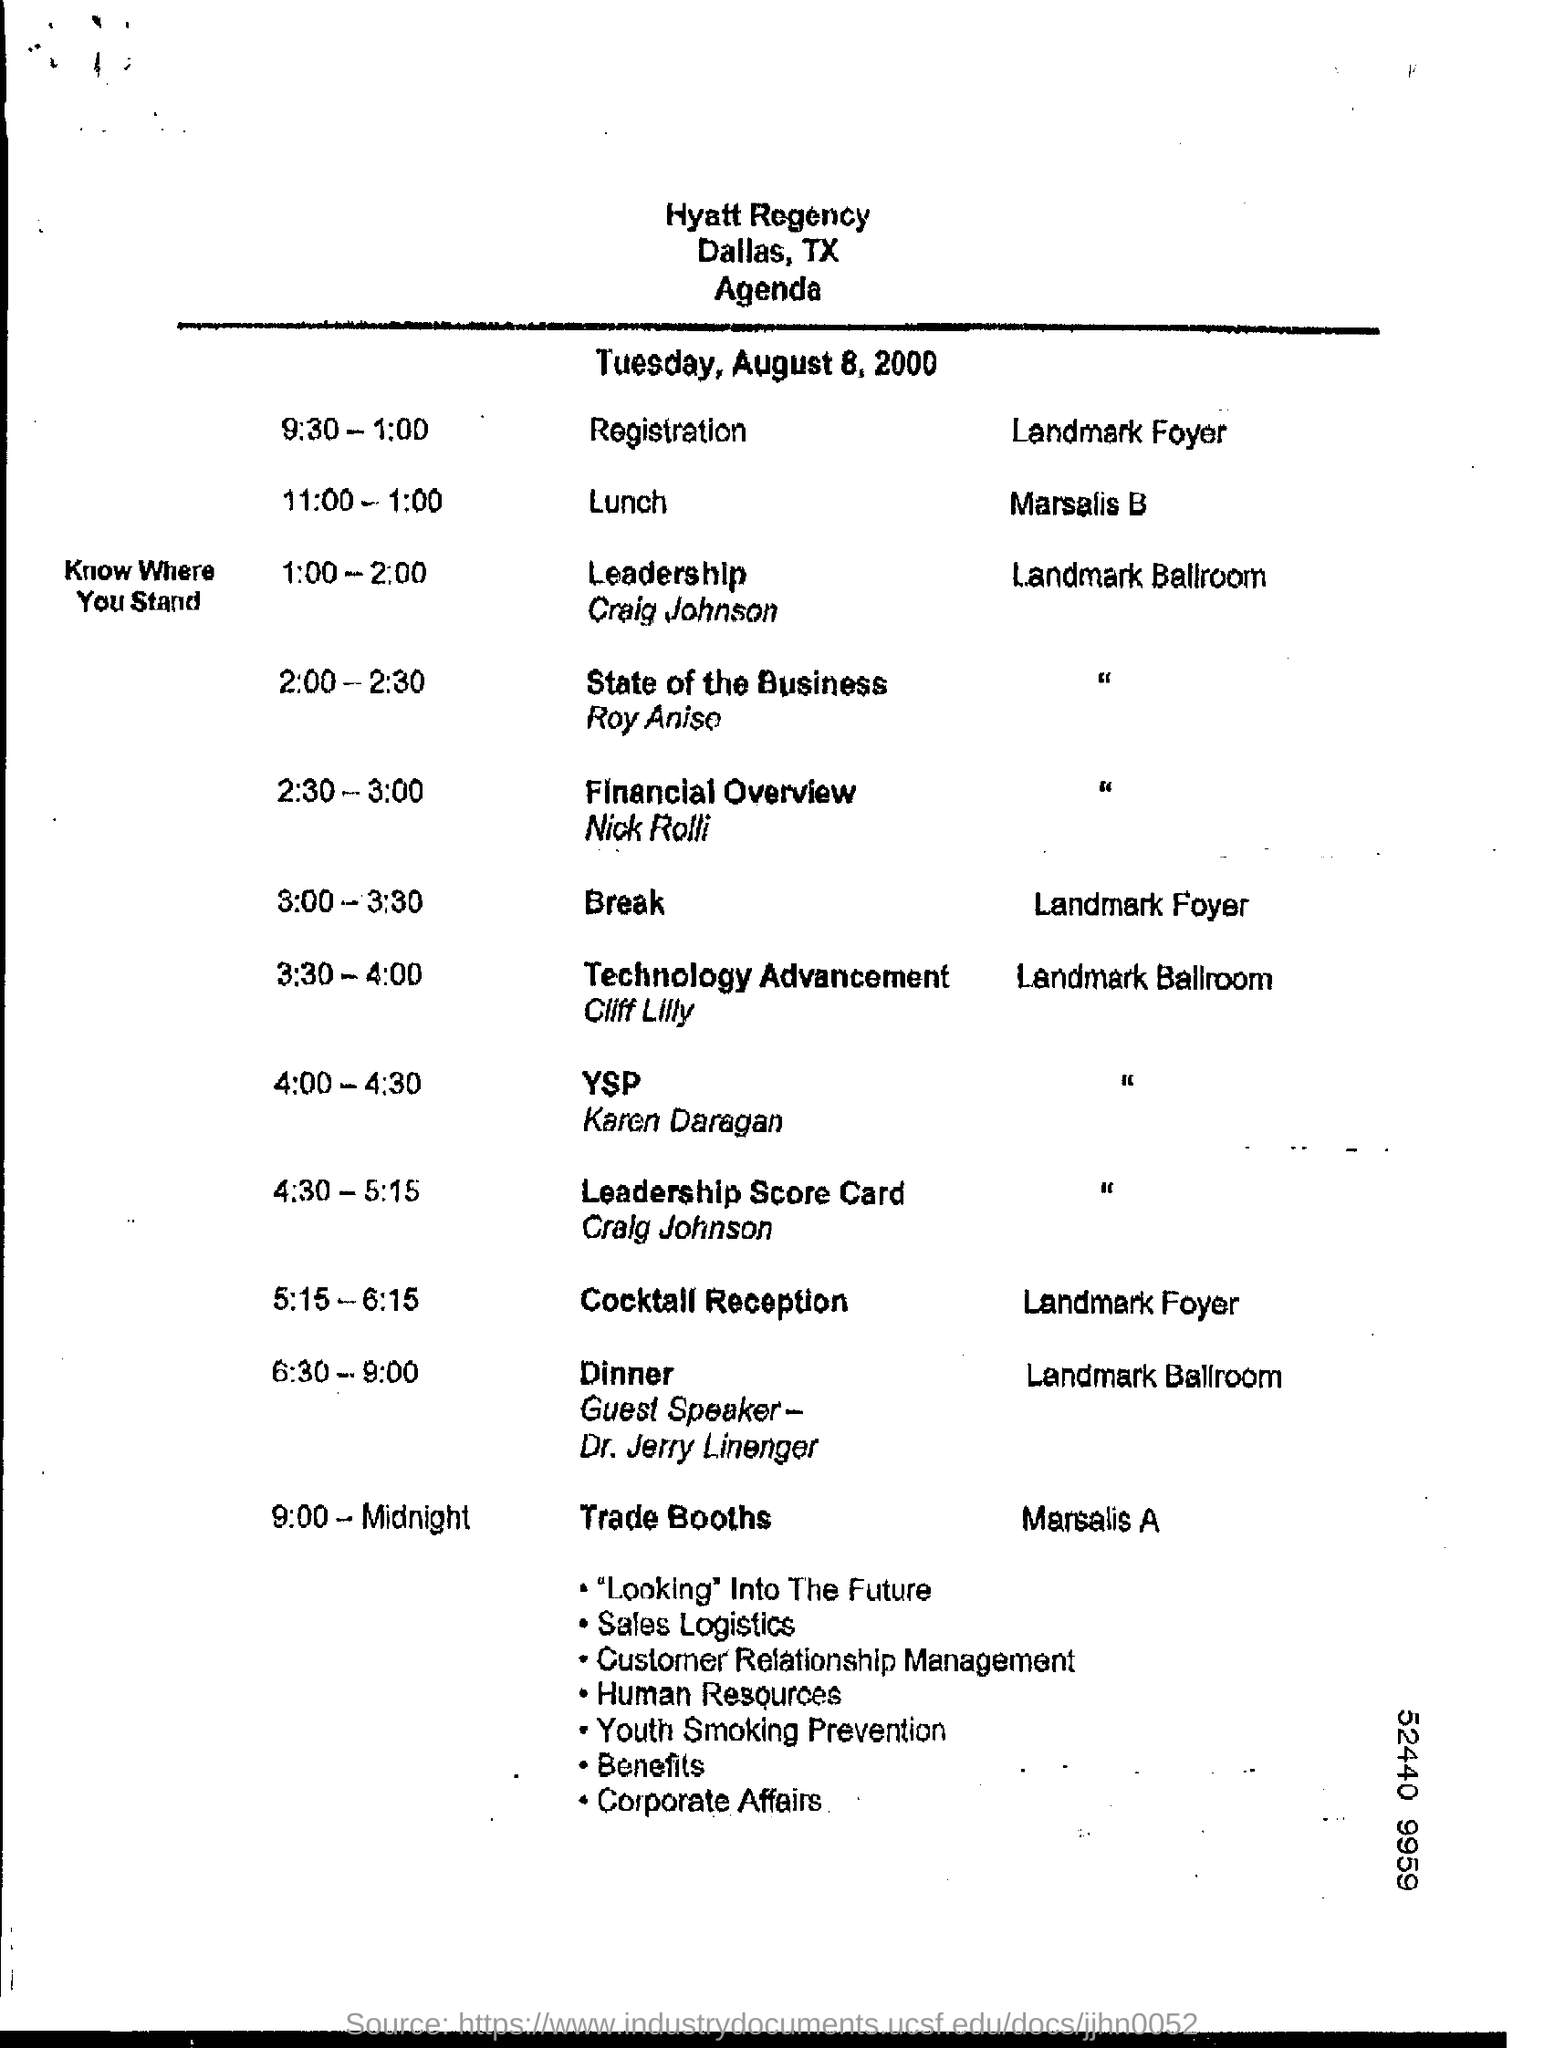Identify some key points in this picture. The break will take place from 3:00 to 3:30. The registration time is from 9:30 to 1:00. 